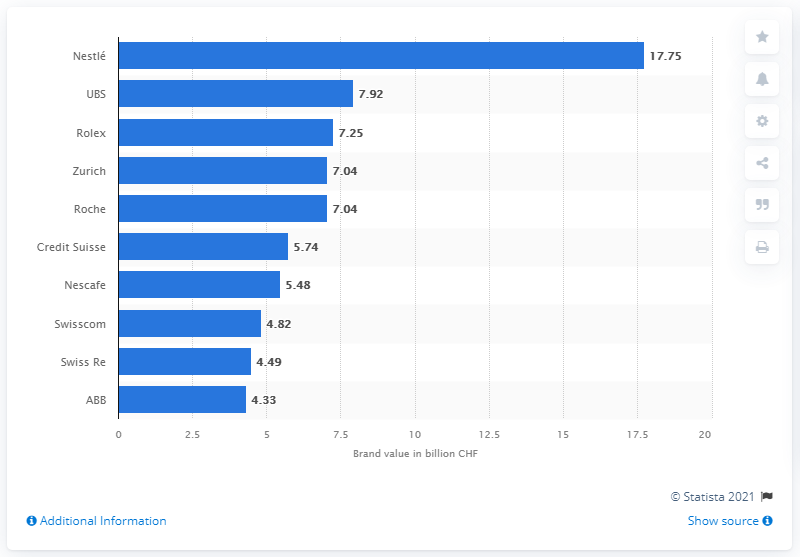Mention a couple of crucial points in this snapshot. Nestlé's second most valuable Swiss brand is a financial services company named UBS. In 2021, Nestlé's brand value was CHF 17.75 billion. 